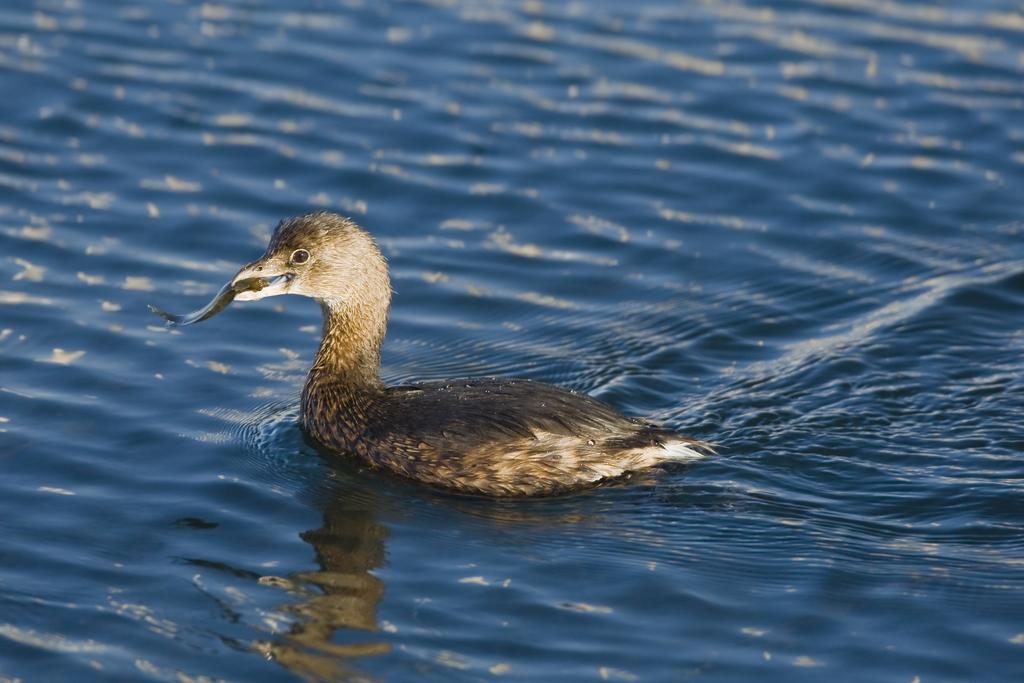In one or two sentences, can you explain what this image depicts? In this image I can see the bird in the water and the bird is in brown and cream color. 